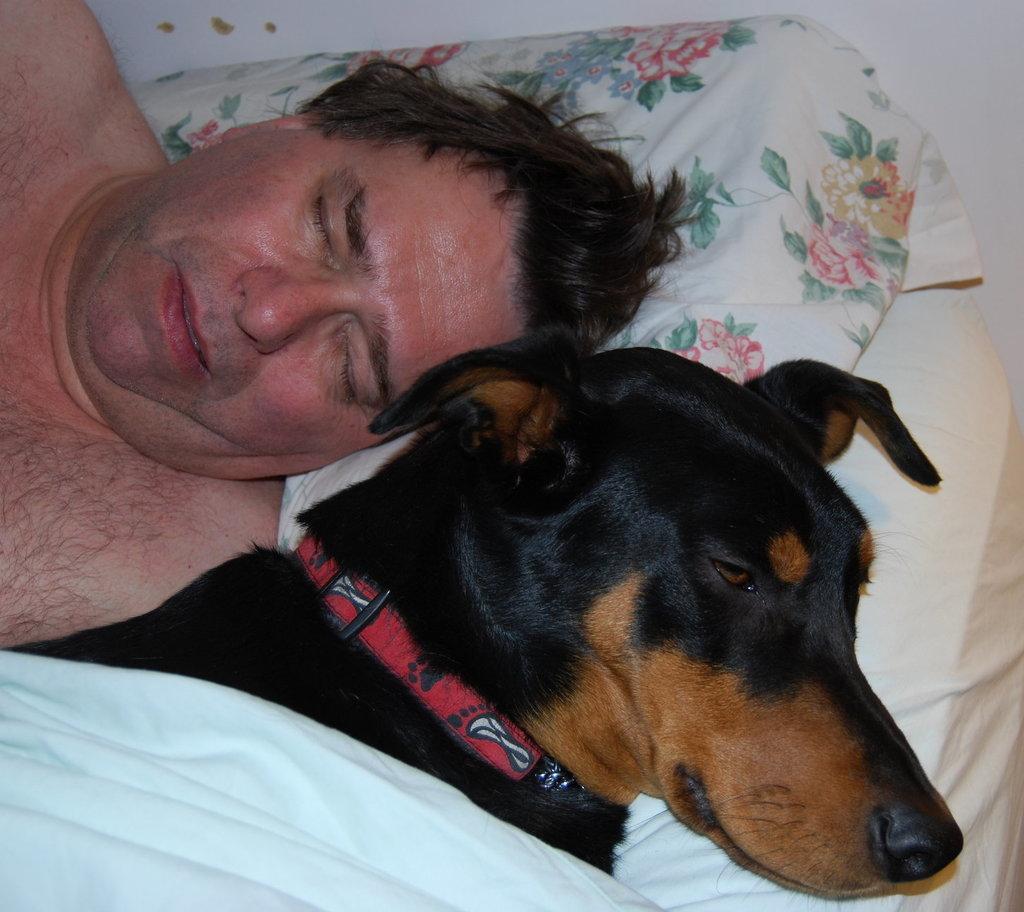Please provide a concise description of this image. In this image I can see a person laying on bed and the person is sleeping and beside the person I can see a dog , on the dog I can see a white color cloth. 